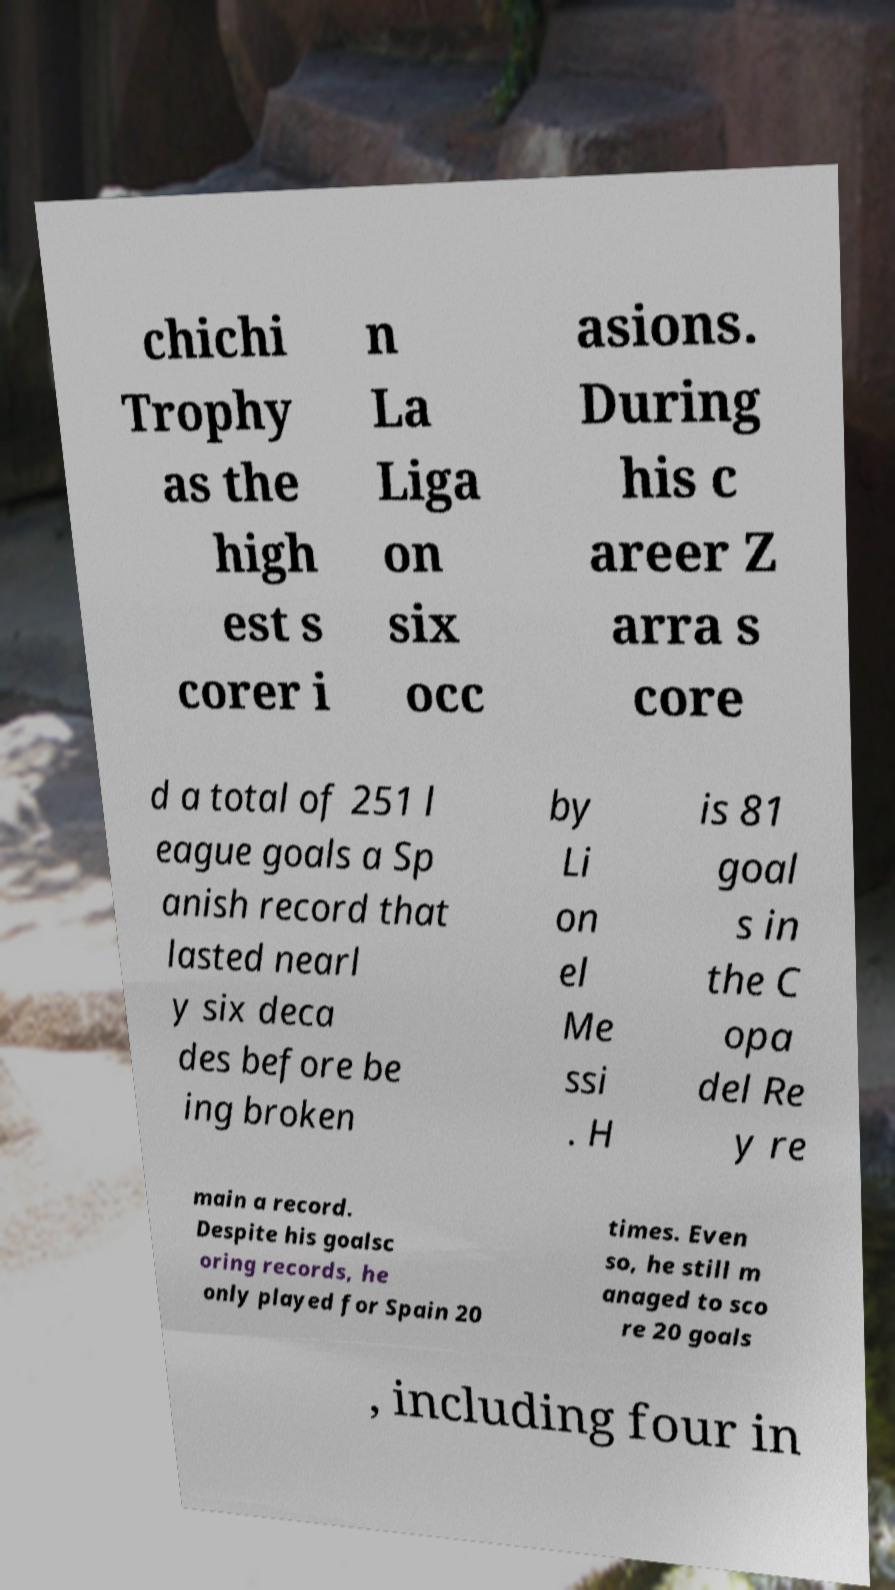Can you read and provide the text displayed in the image?This photo seems to have some interesting text. Can you extract and type it out for me? chichi Trophy as the high est s corer i n La Liga on six occ asions. During his c areer Z arra s core d a total of 251 l eague goals a Sp anish record that lasted nearl y six deca des before be ing broken by Li on el Me ssi . H is 81 goal s in the C opa del Re y re main a record. Despite his goalsc oring records, he only played for Spain 20 times. Even so, he still m anaged to sco re 20 goals , including four in 